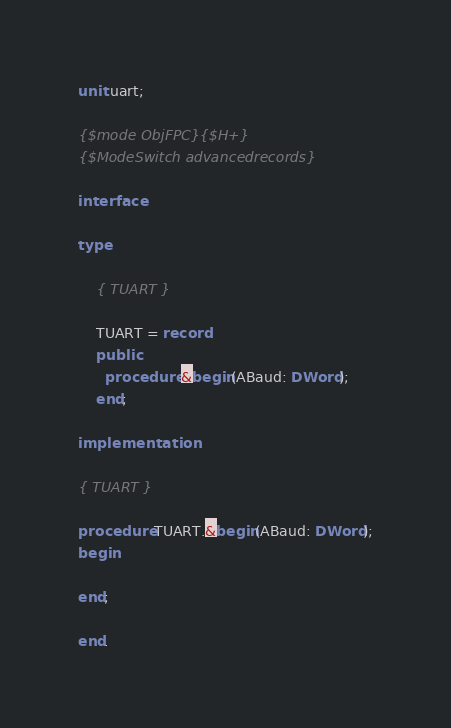<code> <loc_0><loc_0><loc_500><loc_500><_Pascal_>unit uart;

{$mode ObjFPC}{$H+}
{$ModeSwitch advancedrecords}

interface

type

    { TUART }

    TUART = record
    public
      procedure &begin(ABaud: DWord);
    end;

implementation

{ TUART }

procedure TUART.&begin(ABaud: DWord);
begin

end;

end.

</code> 